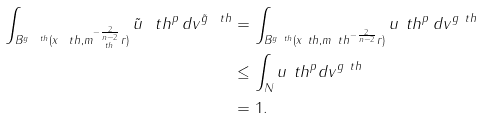<formula> <loc_0><loc_0><loc_500><loc_500>\int _ { B ^ { g _ { \ } t h } ( x _ { \ } t h , m _ { \ t h } ^ { - \frac { 2 } { n - 2 } } r ) } { \tilde { u } _ { \ } t h } ^ { p } \, d v ^ { \tilde { g } _ { \ } t h } & = \int _ { B ^ { g _ { \ } t h } ( x _ { \ } t h , m _ { \ } t h ^ { - \frac { 2 } { n - 2 } } r ) } u _ { \ } t h ^ { p } \, d v ^ { g _ { \ } t h } \\ & \leq \int _ { N } u _ { \ } t h ^ { p } d v ^ { g _ { \ } t h } \\ & = 1 .</formula> 